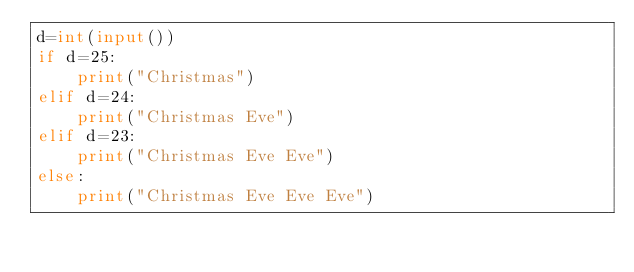Convert code to text. <code><loc_0><loc_0><loc_500><loc_500><_Python_>d=int(input())
if d=25:
    print("Christmas")
elif d=24:
    print("Christmas Eve")
elif d=23:
    print("Christmas Eve Eve")
else:
    print("Christmas Eve Eve Eve")
</code> 